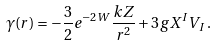<formula> <loc_0><loc_0><loc_500><loc_500>\gamma ( r ) = - \frac { 3 } { 2 } e ^ { - 2 W } \frac { k Z } { r ^ { 2 } } + 3 g X ^ { I } V _ { I } \, .</formula> 